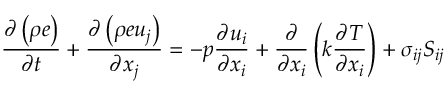<formula> <loc_0><loc_0><loc_500><loc_500>\frac { \partial \left ( \rho e \right ) } { \partial t } + \frac { \partial \left ( \rho e u _ { j } \right ) } { \partial x _ { j } } = - p \frac { \partial u _ { i } } { \partial x _ { i } } + \frac { \partial } { \partial x _ { i } } \left ( k \frac { \partial T } { \partial x _ { i } } \right ) + \sigma _ { i j } S _ { i j }</formula> 